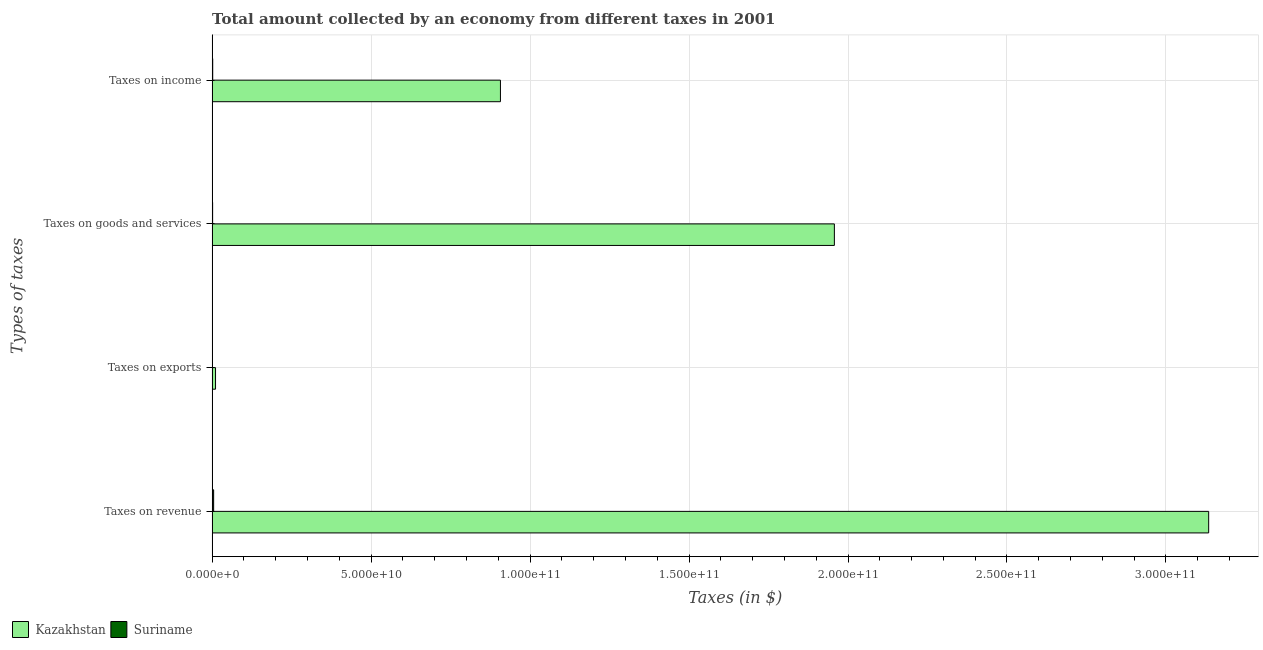How many groups of bars are there?
Provide a short and direct response. 4. Are the number of bars per tick equal to the number of legend labels?
Provide a succinct answer. Yes. Are the number of bars on each tick of the Y-axis equal?
Your response must be concise. Yes. What is the label of the 2nd group of bars from the top?
Offer a very short reply. Taxes on goods and services. What is the amount collected as tax on goods in Suriname?
Provide a succinct answer. 1.56e+08. Across all countries, what is the maximum amount collected as tax on goods?
Offer a terse response. 1.96e+11. Across all countries, what is the minimum amount collected as tax on goods?
Provide a succinct answer. 1.56e+08. In which country was the amount collected as tax on revenue maximum?
Your response must be concise. Kazakhstan. In which country was the amount collected as tax on goods minimum?
Your response must be concise. Suriname. What is the total amount collected as tax on revenue in the graph?
Ensure brevity in your answer.  3.14e+11. What is the difference between the amount collected as tax on revenue in Suriname and that in Kazakhstan?
Your answer should be very brief. -3.13e+11. What is the difference between the amount collected as tax on goods in Suriname and the amount collected as tax on exports in Kazakhstan?
Ensure brevity in your answer.  -9.17e+08. What is the average amount collected as tax on income per country?
Your answer should be compact. 4.54e+1. What is the difference between the amount collected as tax on income and amount collected as tax on exports in Suriname?
Make the answer very short. 1.84e+08. What is the ratio of the amount collected as tax on exports in Kazakhstan to that in Suriname?
Keep it short and to the point. 548.03. Is the difference between the amount collected as tax on revenue in Suriname and Kazakhstan greater than the difference between the amount collected as tax on income in Suriname and Kazakhstan?
Offer a very short reply. No. What is the difference between the highest and the second highest amount collected as tax on revenue?
Offer a terse response. 3.13e+11. What is the difference between the highest and the lowest amount collected as tax on revenue?
Your answer should be very brief. 3.13e+11. What does the 1st bar from the top in Taxes on exports represents?
Your answer should be very brief. Suriname. What does the 2nd bar from the bottom in Taxes on exports represents?
Your answer should be very brief. Suriname. Is it the case that in every country, the sum of the amount collected as tax on revenue and amount collected as tax on exports is greater than the amount collected as tax on goods?
Provide a succinct answer. Yes. Are all the bars in the graph horizontal?
Ensure brevity in your answer.  Yes. What is the difference between two consecutive major ticks on the X-axis?
Make the answer very short. 5.00e+1. Where does the legend appear in the graph?
Give a very brief answer. Bottom left. How many legend labels are there?
Offer a terse response. 2. What is the title of the graph?
Provide a succinct answer. Total amount collected by an economy from different taxes in 2001. What is the label or title of the X-axis?
Offer a very short reply. Taxes (in $). What is the label or title of the Y-axis?
Offer a very short reply. Types of taxes. What is the Taxes (in $) of Kazakhstan in Taxes on revenue?
Provide a succinct answer. 3.13e+11. What is the Taxes (in $) of Suriname in Taxes on revenue?
Offer a terse response. 4.78e+08. What is the Taxes (in $) of Kazakhstan in Taxes on exports?
Keep it short and to the point. 1.07e+09. What is the Taxes (in $) of Suriname in Taxes on exports?
Provide a succinct answer. 1.96e+06. What is the Taxes (in $) of Kazakhstan in Taxes on goods and services?
Provide a succinct answer. 1.96e+11. What is the Taxes (in $) of Suriname in Taxes on goods and services?
Make the answer very short. 1.56e+08. What is the Taxes (in $) in Kazakhstan in Taxes on income?
Make the answer very short. 9.07e+1. What is the Taxes (in $) of Suriname in Taxes on income?
Provide a short and direct response. 1.86e+08. Across all Types of taxes, what is the maximum Taxes (in $) of Kazakhstan?
Make the answer very short. 3.13e+11. Across all Types of taxes, what is the maximum Taxes (in $) of Suriname?
Offer a very short reply. 4.78e+08. Across all Types of taxes, what is the minimum Taxes (in $) of Kazakhstan?
Offer a very short reply. 1.07e+09. Across all Types of taxes, what is the minimum Taxes (in $) of Suriname?
Your answer should be very brief. 1.96e+06. What is the total Taxes (in $) in Kazakhstan in the graph?
Offer a very short reply. 6.01e+11. What is the total Taxes (in $) of Suriname in the graph?
Give a very brief answer. 8.22e+08. What is the difference between the Taxes (in $) in Kazakhstan in Taxes on revenue and that in Taxes on exports?
Offer a very short reply. 3.12e+11. What is the difference between the Taxes (in $) of Suriname in Taxes on revenue and that in Taxes on exports?
Make the answer very short. 4.76e+08. What is the difference between the Taxes (in $) in Kazakhstan in Taxes on revenue and that in Taxes on goods and services?
Your answer should be compact. 1.18e+11. What is the difference between the Taxes (in $) in Suriname in Taxes on revenue and that in Taxes on goods and services?
Give a very brief answer. 3.22e+08. What is the difference between the Taxes (in $) of Kazakhstan in Taxes on revenue and that in Taxes on income?
Provide a succinct answer. 2.23e+11. What is the difference between the Taxes (in $) of Suriname in Taxes on revenue and that in Taxes on income?
Ensure brevity in your answer.  2.92e+08. What is the difference between the Taxes (in $) of Kazakhstan in Taxes on exports and that in Taxes on goods and services?
Ensure brevity in your answer.  -1.95e+11. What is the difference between the Taxes (in $) of Suriname in Taxes on exports and that in Taxes on goods and services?
Offer a terse response. -1.54e+08. What is the difference between the Taxes (in $) in Kazakhstan in Taxes on exports and that in Taxes on income?
Your answer should be very brief. -8.96e+1. What is the difference between the Taxes (in $) of Suriname in Taxes on exports and that in Taxes on income?
Your answer should be compact. -1.84e+08. What is the difference between the Taxes (in $) in Kazakhstan in Taxes on goods and services and that in Taxes on income?
Provide a short and direct response. 1.05e+11. What is the difference between the Taxes (in $) in Suriname in Taxes on goods and services and that in Taxes on income?
Your answer should be very brief. -2.94e+07. What is the difference between the Taxes (in $) in Kazakhstan in Taxes on revenue and the Taxes (in $) in Suriname in Taxes on exports?
Make the answer very short. 3.13e+11. What is the difference between the Taxes (in $) of Kazakhstan in Taxes on revenue and the Taxes (in $) of Suriname in Taxes on goods and services?
Your answer should be very brief. 3.13e+11. What is the difference between the Taxes (in $) in Kazakhstan in Taxes on revenue and the Taxes (in $) in Suriname in Taxes on income?
Ensure brevity in your answer.  3.13e+11. What is the difference between the Taxes (in $) of Kazakhstan in Taxes on exports and the Taxes (in $) of Suriname in Taxes on goods and services?
Keep it short and to the point. 9.17e+08. What is the difference between the Taxes (in $) of Kazakhstan in Taxes on exports and the Taxes (in $) of Suriname in Taxes on income?
Give a very brief answer. 8.88e+08. What is the difference between the Taxes (in $) of Kazakhstan in Taxes on goods and services and the Taxes (in $) of Suriname in Taxes on income?
Provide a short and direct response. 1.96e+11. What is the average Taxes (in $) of Kazakhstan per Types of taxes?
Your response must be concise. 1.50e+11. What is the average Taxes (in $) in Suriname per Types of taxes?
Offer a terse response. 2.05e+08. What is the difference between the Taxes (in $) in Kazakhstan and Taxes (in $) in Suriname in Taxes on revenue?
Make the answer very short. 3.13e+11. What is the difference between the Taxes (in $) in Kazakhstan and Taxes (in $) in Suriname in Taxes on exports?
Your response must be concise. 1.07e+09. What is the difference between the Taxes (in $) in Kazakhstan and Taxes (in $) in Suriname in Taxes on goods and services?
Provide a short and direct response. 1.96e+11. What is the difference between the Taxes (in $) in Kazakhstan and Taxes (in $) in Suriname in Taxes on income?
Give a very brief answer. 9.05e+1. What is the ratio of the Taxes (in $) of Kazakhstan in Taxes on revenue to that in Taxes on exports?
Give a very brief answer. 292.01. What is the ratio of the Taxes (in $) of Suriname in Taxes on revenue to that in Taxes on exports?
Provide a succinct answer. 243.98. What is the ratio of the Taxes (in $) of Kazakhstan in Taxes on revenue to that in Taxes on goods and services?
Ensure brevity in your answer.  1.6. What is the ratio of the Taxes (in $) in Suriname in Taxes on revenue to that in Taxes on goods and services?
Offer a terse response. 3.06. What is the ratio of the Taxes (in $) of Kazakhstan in Taxes on revenue to that in Taxes on income?
Your response must be concise. 3.46. What is the ratio of the Taxes (in $) of Suriname in Taxes on revenue to that in Taxes on income?
Make the answer very short. 2.57. What is the ratio of the Taxes (in $) of Kazakhstan in Taxes on exports to that in Taxes on goods and services?
Keep it short and to the point. 0.01. What is the ratio of the Taxes (in $) of Suriname in Taxes on exports to that in Taxes on goods and services?
Offer a terse response. 0.01. What is the ratio of the Taxes (in $) in Kazakhstan in Taxes on exports to that in Taxes on income?
Keep it short and to the point. 0.01. What is the ratio of the Taxes (in $) of Suriname in Taxes on exports to that in Taxes on income?
Your answer should be compact. 0.01. What is the ratio of the Taxes (in $) in Kazakhstan in Taxes on goods and services to that in Taxes on income?
Offer a terse response. 2.16. What is the ratio of the Taxes (in $) of Suriname in Taxes on goods and services to that in Taxes on income?
Offer a terse response. 0.84. What is the difference between the highest and the second highest Taxes (in $) of Kazakhstan?
Give a very brief answer. 1.18e+11. What is the difference between the highest and the second highest Taxes (in $) in Suriname?
Your answer should be compact. 2.92e+08. What is the difference between the highest and the lowest Taxes (in $) in Kazakhstan?
Provide a succinct answer. 3.12e+11. What is the difference between the highest and the lowest Taxes (in $) in Suriname?
Your answer should be very brief. 4.76e+08. 